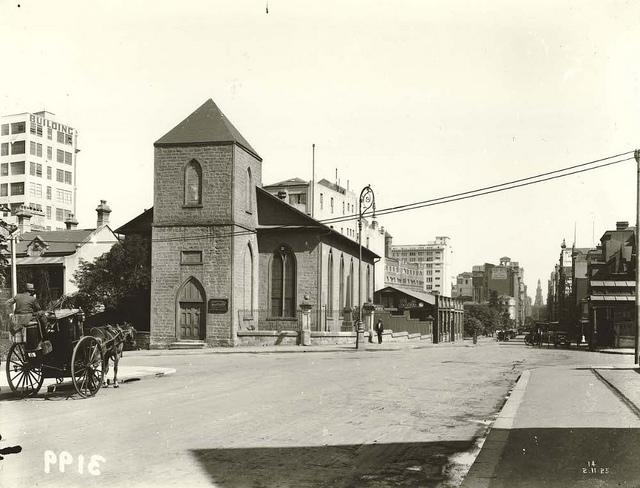Why were stairways part of the outside of the building?
Answer briefly. To get to roof. Is there a horse carriage on the street?
Keep it brief. Yes. Is this a modern day picture?
Be succinct. No. How many horses?
Quick response, please. 1. What letters appear at the bottom left?
Quick response, please. Pie. 